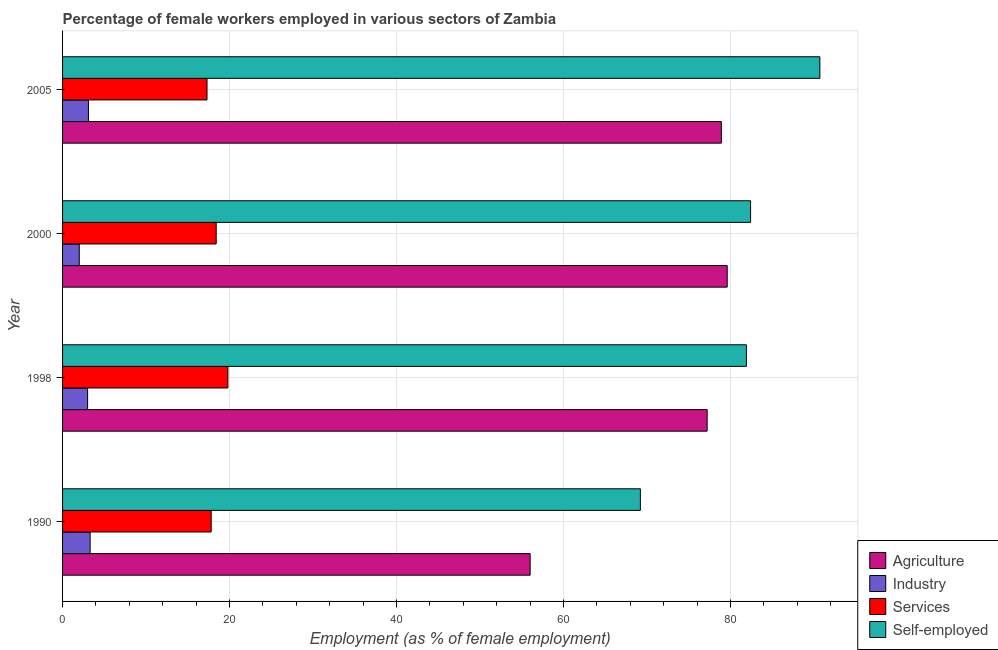How many different coloured bars are there?
Keep it short and to the point. 4. How many bars are there on the 3rd tick from the top?
Your response must be concise. 4. What is the percentage of female workers in services in 2000?
Offer a terse response. 18.4. Across all years, what is the maximum percentage of female workers in agriculture?
Keep it short and to the point. 79.6. Across all years, what is the minimum percentage of self employed female workers?
Ensure brevity in your answer.  69.2. In which year was the percentage of female workers in agriculture minimum?
Your answer should be compact. 1990. What is the total percentage of female workers in services in the graph?
Your answer should be compact. 73.3. What is the difference between the percentage of female workers in agriculture in 2005 and the percentage of female workers in services in 2000?
Give a very brief answer. 60.5. What is the average percentage of female workers in services per year?
Offer a terse response. 18.32. In the year 1998, what is the difference between the percentage of female workers in agriculture and percentage of female workers in services?
Your response must be concise. 57.4. What is the ratio of the percentage of female workers in industry in 1998 to that in 2000?
Give a very brief answer. 1.5. Is the percentage of self employed female workers in 1998 less than that in 2005?
Offer a very short reply. Yes. What is the difference between the highest and the second highest percentage of female workers in agriculture?
Ensure brevity in your answer.  0.7. What is the difference between the highest and the lowest percentage of female workers in industry?
Your answer should be compact. 1.3. What does the 3rd bar from the top in 1990 represents?
Ensure brevity in your answer.  Industry. What does the 3rd bar from the bottom in 2000 represents?
Ensure brevity in your answer.  Services. Are all the bars in the graph horizontal?
Your answer should be compact. Yes. How many years are there in the graph?
Ensure brevity in your answer.  4. What is the difference between two consecutive major ticks on the X-axis?
Your answer should be very brief. 20. Are the values on the major ticks of X-axis written in scientific E-notation?
Your response must be concise. No. Does the graph contain any zero values?
Your answer should be very brief. No. Where does the legend appear in the graph?
Provide a succinct answer. Bottom right. How many legend labels are there?
Ensure brevity in your answer.  4. How are the legend labels stacked?
Ensure brevity in your answer.  Vertical. What is the title of the graph?
Offer a terse response. Percentage of female workers employed in various sectors of Zambia. What is the label or title of the X-axis?
Your answer should be very brief. Employment (as % of female employment). What is the label or title of the Y-axis?
Provide a short and direct response. Year. What is the Employment (as % of female employment) of Industry in 1990?
Your answer should be very brief. 3.3. What is the Employment (as % of female employment) of Services in 1990?
Offer a terse response. 17.8. What is the Employment (as % of female employment) of Self-employed in 1990?
Your answer should be very brief. 69.2. What is the Employment (as % of female employment) of Agriculture in 1998?
Provide a short and direct response. 77.2. What is the Employment (as % of female employment) in Industry in 1998?
Provide a short and direct response. 3. What is the Employment (as % of female employment) in Services in 1998?
Your answer should be very brief. 19.8. What is the Employment (as % of female employment) in Self-employed in 1998?
Keep it short and to the point. 81.9. What is the Employment (as % of female employment) of Agriculture in 2000?
Offer a very short reply. 79.6. What is the Employment (as % of female employment) in Industry in 2000?
Make the answer very short. 2. What is the Employment (as % of female employment) in Services in 2000?
Your response must be concise. 18.4. What is the Employment (as % of female employment) of Self-employed in 2000?
Provide a succinct answer. 82.4. What is the Employment (as % of female employment) in Agriculture in 2005?
Your answer should be compact. 78.9. What is the Employment (as % of female employment) of Industry in 2005?
Give a very brief answer. 3.1. What is the Employment (as % of female employment) of Services in 2005?
Your response must be concise. 17.3. What is the Employment (as % of female employment) of Self-employed in 2005?
Make the answer very short. 90.7. Across all years, what is the maximum Employment (as % of female employment) in Agriculture?
Your answer should be very brief. 79.6. Across all years, what is the maximum Employment (as % of female employment) in Industry?
Keep it short and to the point. 3.3. Across all years, what is the maximum Employment (as % of female employment) in Services?
Give a very brief answer. 19.8. Across all years, what is the maximum Employment (as % of female employment) of Self-employed?
Keep it short and to the point. 90.7. Across all years, what is the minimum Employment (as % of female employment) in Services?
Offer a very short reply. 17.3. Across all years, what is the minimum Employment (as % of female employment) of Self-employed?
Give a very brief answer. 69.2. What is the total Employment (as % of female employment) in Agriculture in the graph?
Your response must be concise. 291.7. What is the total Employment (as % of female employment) in Industry in the graph?
Provide a short and direct response. 11.4. What is the total Employment (as % of female employment) of Services in the graph?
Make the answer very short. 73.3. What is the total Employment (as % of female employment) in Self-employed in the graph?
Make the answer very short. 324.2. What is the difference between the Employment (as % of female employment) in Agriculture in 1990 and that in 1998?
Provide a short and direct response. -21.2. What is the difference between the Employment (as % of female employment) of Industry in 1990 and that in 1998?
Your answer should be very brief. 0.3. What is the difference between the Employment (as % of female employment) of Services in 1990 and that in 1998?
Provide a short and direct response. -2. What is the difference between the Employment (as % of female employment) of Agriculture in 1990 and that in 2000?
Keep it short and to the point. -23.6. What is the difference between the Employment (as % of female employment) in Self-employed in 1990 and that in 2000?
Your answer should be compact. -13.2. What is the difference between the Employment (as % of female employment) in Agriculture in 1990 and that in 2005?
Keep it short and to the point. -22.9. What is the difference between the Employment (as % of female employment) of Services in 1990 and that in 2005?
Your response must be concise. 0.5. What is the difference between the Employment (as % of female employment) of Self-employed in 1990 and that in 2005?
Give a very brief answer. -21.5. What is the difference between the Employment (as % of female employment) of Services in 1998 and that in 2000?
Keep it short and to the point. 1.4. What is the difference between the Employment (as % of female employment) in Industry in 1998 and that in 2005?
Give a very brief answer. -0.1. What is the difference between the Employment (as % of female employment) of Self-employed in 1998 and that in 2005?
Your answer should be compact. -8.8. What is the difference between the Employment (as % of female employment) of Agriculture in 2000 and that in 2005?
Offer a very short reply. 0.7. What is the difference between the Employment (as % of female employment) in Agriculture in 1990 and the Employment (as % of female employment) in Services in 1998?
Keep it short and to the point. 36.2. What is the difference between the Employment (as % of female employment) of Agriculture in 1990 and the Employment (as % of female employment) of Self-employed in 1998?
Ensure brevity in your answer.  -25.9. What is the difference between the Employment (as % of female employment) of Industry in 1990 and the Employment (as % of female employment) of Services in 1998?
Make the answer very short. -16.5. What is the difference between the Employment (as % of female employment) in Industry in 1990 and the Employment (as % of female employment) in Self-employed in 1998?
Provide a short and direct response. -78.6. What is the difference between the Employment (as % of female employment) of Services in 1990 and the Employment (as % of female employment) of Self-employed in 1998?
Provide a short and direct response. -64.1. What is the difference between the Employment (as % of female employment) in Agriculture in 1990 and the Employment (as % of female employment) in Industry in 2000?
Make the answer very short. 54. What is the difference between the Employment (as % of female employment) of Agriculture in 1990 and the Employment (as % of female employment) of Services in 2000?
Ensure brevity in your answer.  37.6. What is the difference between the Employment (as % of female employment) in Agriculture in 1990 and the Employment (as % of female employment) in Self-employed in 2000?
Provide a short and direct response. -26.4. What is the difference between the Employment (as % of female employment) in Industry in 1990 and the Employment (as % of female employment) in Services in 2000?
Keep it short and to the point. -15.1. What is the difference between the Employment (as % of female employment) in Industry in 1990 and the Employment (as % of female employment) in Self-employed in 2000?
Your response must be concise. -79.1. What is the difference between the Employment (as % of female employment) of Services in 1990 and the Employment (as % of female employment) of Self-employed in 2000?
Make the answer very short. -64.6. What is the difference between the Employment (as % of female employment) of Agriculture in 1990 and the Employment (as % of female employment) of Industry in 2005?
Offer a very short reply. 52.9. What is the difference between the Employment (as % of female employment) of Agriculture in 1990 and the Employment (as % of female employment) of Services in 2005?
Make the answer very short. 38.7. What is the difference between the Employment (as % of female employment) of Agriculture in 1990 and the Employment (as % of female employment) of Self-employed in 2005?
Provide a short and direct response. -34.7. What is the difference between the Employment (as % of female employment) in Industry in 1990 and the Employment (as % of female employment) in Self-employed in 2005?
Your answer should be very brief. -87.4. What is the difference between the Employment (as % of female employment) in Services in 1990 and the Employment (as % of female employment) in Self-employed in 2005?
Your answer should be compact. -72.9. What is the difference between the Employment (as % of female employment) in Agriculture in 1998 and the Employment (as % of female employment) in Industry in 2000?
Give a very brief answer. 75.2. What is the difference between the Employment (as % of female employment) in Agriculture in 1998 and the Employment (as % of female employment) in Services in 2000?
Give a very brief answer. 58.8. What is the difference between the Employment (as % of female employment) of Agriculture in 1998 and the Employment (as % of female employment) of Self-employed in 2000?
Provide a succinct answer. -5.2. What is the difference between the Employment (as % of female employment) in Industry in 1998 and the Employment (as % of female employment) in Services in 2000?
Your answer should be very brief. -15.4. What is the difference between the Employment (as % of female employment) of Industry in 1998 and the Employment (as % of female employment) of Self-employed in 2000?
Offer a very short reply. -79.4. What is the difference between the Employment (as % of female employment) in Services in 1998 and the Employment (as % of female employment) in Self-employed in 2000?
Offer a terse response. -62.6. What is the difference between the Employment (as % of female employment) in Agriculture in 1998 and the Employment (as % of female employment) in Industry in 2005?
Give a very brief answer. 74.1. What is the difference between the Employment (as % of female employment) of Agriculture in 1998 and the Employment (as % of female employment) of Services in 2005?
Your answer should be compact. 59.9. What is the difference between the Employment (as % of female employment) in Agriculture in 1998 and the Employment (as % of female employment) in Self-employed in 2005?
Keep it short and to the point. -13.5. What is the difference between the Employment (as % of female employment) in Industry in 1998 and the Employment (as % of female employment) in Services in 2005?
Keep it short and to the point. -14.3. What is the difference between the Employment (as % of female employment) of Industry in 1998 and the Employment (as % of female employment) of Self-employed in 2005?
Ensure brevity in your answer.  -87.7. What is the difference between the Employment (as % of female employment) of Services in 1998 and the Employment (as % of female employment) of Self-employed in 2005?
Provide a succinct answer. -70.9. What is the difference between the Employment (as % of female employment) of Agriculture in 2000 and the Employment (as % of female employment) of Industry in 2005?
Offer a very short reply. 76.5. What is the difference between the Employment (as % of female employment) of Agriculture in 2000 and the Employment (as % of female employment) of Services in 2005?
Offer a very short reply. 62.3. What is the difference between the Employment (as % of female employment) of Industry in 2000 and the Employment (as % of female employment) of Services in 2005?
Ensure brevity in your answer.  -15.3. What is the difference between the Employment (as % of female employment) of Industry in 2000 and the Employment (as % of female employment) of Self-employed in 2005?
Your answer should be very brief. -88.7. What is the difference between the Employment (as % of female employment) in Services in 2000 and the Employment (as % of female employment) in Self-employed in 2005?
Keep it short and to the point. -72.3. What is the average Employment (as % of female employment) in Agriculture per year?
Your answer should be compact. 72.92. What is the average Employment (as % of female employment) of Industry per year?
Your answer should be compact. 2.85. What is the average Employment (as % of female employment) in Services per year?
Your response must be concise. 18.32. What is the average Employment (as % of female employment) of Self-employed per year?
Give a very brief answer. 81.05. In the year 1990, what is the difference between the Employment (as % of female employment) in Agriculture and Employment (as % of female employment) in Industry?
Ensure brevity in your answer.  52.7. In the year 1990, what is the difference between the Employment (as % of female employment) in Agriculture and Employment (as % of female employment) in Services?
Offer a very short reply. 38.2. In the year 1990, what is the difference between the Employment (as % of female employment) in Agriculture and Employment (as % of female employment) in Self-employed?
Provide a short and direct response. -13.2. In the year 1990, what is the difference between the Employment (as % of female employment) in Industry and Employment (as % of female employment) in Services?
Make the answer very short. -14.5. In the year 1990, what is the difference between the Employment (as % of female employment) of Industry and Employment (as % of female employment) of Self-employed?
Your response must be concise. -65.9. In the year 1990, what is the difference between the Employment (as % of female employment) in Services and Employment (as % of female employment) in Self-employed?
Give a very brief answer. -51.4. In the year 1998, what is the difference between the Employment (as % of female employment) in Agriculture and Employment (as % of female employment) in Industry?
Your answer should be very brief. 74.2. In the year 1998, what is the difference between the Employment (as % of female employment) in Agriculture and Employment (as % of female employment) in Services?
Ensure brevity in your answer.  57.4. In the year 1998, what is the difference between the Employment (as % of female employment) of Industry and Employment (as % of female employment) of Services?
Your answer should be very brief. -16.8. In the year 1998, what is the difference between the Employment (as % of female employment) in Industry and Employment (as % of female employment) in Self-employed?
Offer a very short reply. -78.9. In the year 1998, what is the difference between the Employment (as % of female employment) in Services and Employment (as % of female employment) in Self-employed?
Offer a terse response. -62.1. In the year 2000, what is the difference between the Employment (as % of female employment) in Agriculture and Employment (as % of female employment) in Industry?
Give a very brief answer. 77.6. In the year 2000, what is the difference between the Employment (as % of female employment) in Agriculture and Employment (as % of female employment) in Services?
Make the answer very short. 61.2. In the year 2000, what is the difference between the Employment (as % of female employment) of Industry and Employment (as % of female employment) of Services?
Ensure brevity in your answer.  -16.4. In the year 2000, what is the difference between the Employment (as % of female employment) in Industry and Employment (as % of female employment) in Self-employed?
Ensure brevity in your answer.  -80.4. In the year 2000, what is the difference between the Employment (as % of female employment) of Services and Employment (as % of female employment) of Self-employed?
Make the answer very short. -64. In the year 2005, what is the difference between the Employment (as % of female employment) of Agriculture and Employment (as % of female employment) of Industry?
Provide a succinct answer. 75.8. In the year 2005, what is the difference between the Employment (as % of female employment) in Agriculture and Employment (as % of female employment) in Services?
Keep it short and to the point. 61.6. In the year 2005, what is the difference between the Employment (as % of female employment) of Industry and Employment (as % of female employment) of Self-employed?
Make the answer very short. -87.6. In the year 2005, what is the difference between the Employment (as % of female employment) of Services and Employment (as % of female employment) of Self-employed?
Give a very brief answer. -73.4. What is the ratio of the Employment (as % of female employment) of Agriculture in 1990 to that in 1998?
Offer a terse response. 0.73. What is the ratio of the Employment (as % of female employment) of Services in 1990 to that in 1998?
Ensure brevity in your answer.  0.9. What is the ratio of the Employment (as % of female employment) of Self-employed in 1990 to that in 1998?
Keep it short and to the point. 0.84. What is the ratio of the Employment (as % of female employment) in Agriculture in 1990 to that in 2000?
Make the answer very short. 0.7. What is the ratio of the Employment (as % of female employment) of Industry in 1990 to that in 2000?
Your answer should be compact. 1.65. What is the ratio of the Employment (as % of female employment) of Services in 1990 to that in 2000?
Provide a succinct answer. 0.97. What is the ratio of the Employment (as % of female employment) in Self-employed in 1990 to that in 2000?
Keep it short and to the point. 0.84. What is the ratio of the Employment (as % of female employment) in Agriculture in 1990 to that in 2005?
Provide a succinct answer. 0.71. What is the ratio of the Employment (as % of female employment) in Industry in 1990 to that in 2005?
Your answer should be compact. 1.06. What is the ratio of the Employment (as % of female employment) in Services in 1990 to that in 2005?
Ensure brevity in your answer.  1.03. What is the ratio of the Employment (as % of female employment) in Self-employed in 1990 to that in 2005?
Keep it short and to the point. 0.76. What is the ratio of the Employment (as % of female employment) of Agriculture in 1998 to that in 2000?
Keep it short and to the point. 0.97. What is the ratio of the Employment (as % of female employment) in Industry in 1998 to that in 2000?
Offer a very short reply. 1.5. What is the ratio of the Employment (as % of female employment) in Services in 1998 to that in 2000?
Your answer should be compact. 1.08. What is the ratio of the Employment (as % of female employment) of Self-employed in 1998 to that in 2000?
Give a very brief answer. 0.99. What is the ratio of the Employment (as % of female employment) of Agriculture in 1998 to that in 2005?
Provide a succinct answer. 0.98. What is the ratio of the Employment (as % of female employment) of Services in 1998 to that in 2005?
Your answer should be very brief. 1.14. What is the ratio of the Employment (as % of female employment) in Self-employed in 1998 to that in 2005?
Offer a terse response. 0.9. What is the ratio of the Employment (as % of female employment) in Agriculture in 2000 to that in 2005?
Make the answer very short. 1.01. What is the ratio of the Employment (as % of female employment) of Industry in 2000 to that in 2005?
Your answer should be very brief. 0.65. What is the ratio of the Employment (as % of female employment) in Services in 2000 to that in 2005?
Your answer should be very brief. 1.06. What is the ratio of the Employment (as % of female employment) in Self-employed in 2000 to that in 2005?
Your answer should be compact. 0.91. What is the difference between the highest and the second highest Employment (as % of female employment) in Agriculture?
Keep it short and to the point. 0.7. What is the difference between the highest and the second highest Employment (as % of female employment) of Services?
Make the answer very short. 1.4. What is the difference between the highest and the second highest Employment (as % of female employment) in Self-employed?
Offer a very short reply. 8.3. What is the difference between the highest and the lowest Employment (as % of female employment) of Agriculture?
Your response must be concise. 23.6. What is the difference between the highest and the lowest Employment (as % of female employment) in Industry?
Keep it short and to the point. 1.3. What is the difference between the highest and the lowest Employment (as % of female employment) in Services?
Your response must be concise. 2.5. What is the difference between the highest and the lowest Employment (as % of female employment) of Self-employed?
Ensure brevity in your answer.  21.5. 